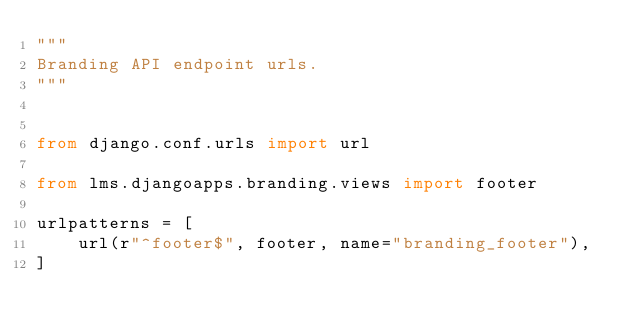Convert code to text. <code><loc_0><loc_0><loc_500><loc_500><_Python_>"""
Branding API endpoint urls.
"""


from django.conf.urls import url

from lms.djangoapps.branding.views import footer

urlpatterns = [
    url(r"^footer$", footer, name="branding_footer"),
]
</code> 